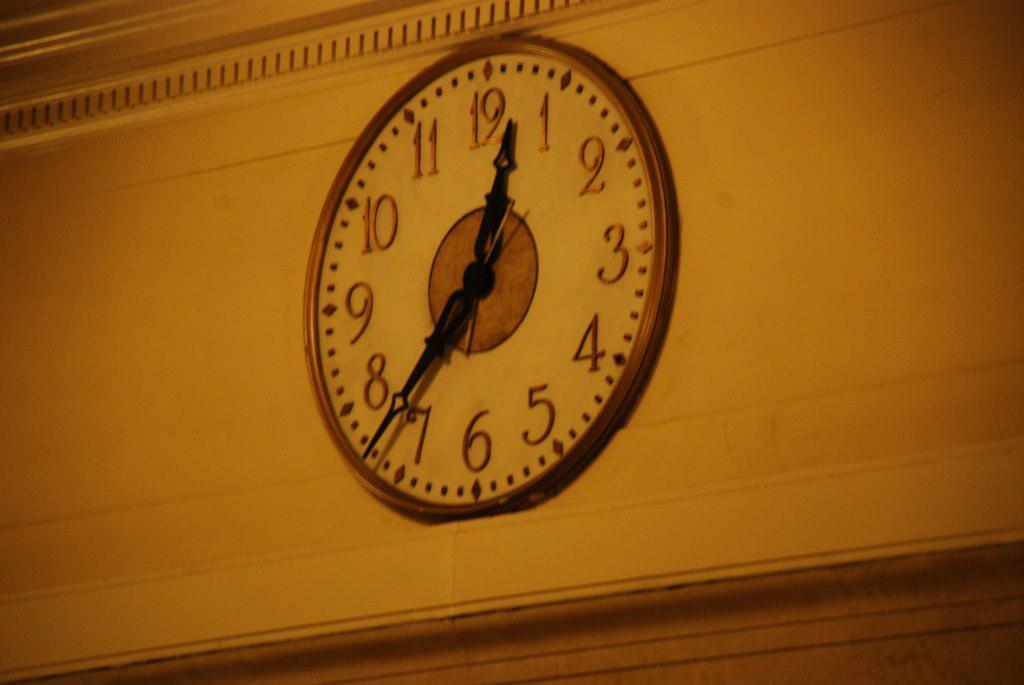<image>
Describe the image concisely. An analog clock displays the time at "12:37". 